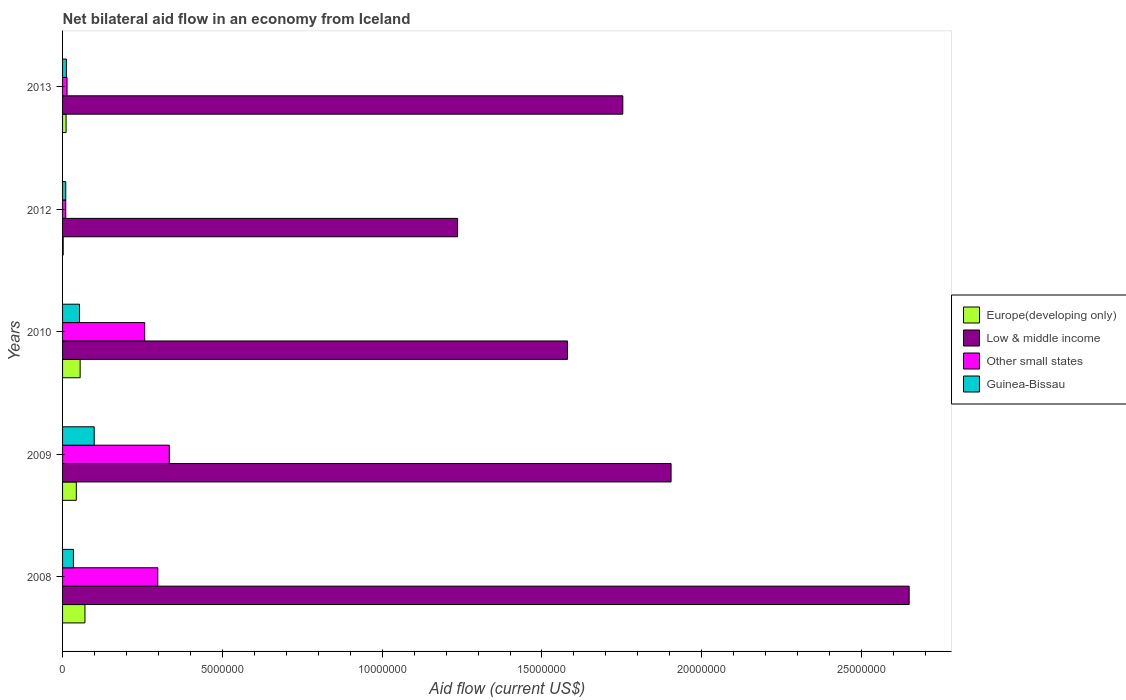Are the number of bars per tick equal to the number of legend labels?
Your answer should be very brief. Yes. How many bars are there on the 5th tick from the bottom?
Ensure brevity in your answer.  4. In how many cases, is the number of bars for a given year not equal to the number of legend labels?
Your response must be concise. 0. What is the net bilateral aid flow in Europe(developing only) in 2013?
Your response must be concise. 1.10e+05. Across all years, what is the maximum net bilateral aid flow in Guinea-Bissau?
Make the answer very short. 9.90e+05. Across all years, what is the minimum net bilateral aid flow in Low & middle income?
Provide a succinct answer. 1.24e+07. What is the total net bilateral aid flow in Guinea-Bissau in the graph?
Your answer should be very brief. 2.08e+06. What is the difference between the net bilateral aid flow in Guinea-Bissau in 2008 and that in 2012?
Ensure brevity in your answer.  2.40e+05. What is the difference between the net bilateral aid flow in Other small states in 2008 and the net bilateral aid flow in Low & middle income in 2012?
Provide a short and direct response. -9.38e+06. What is the average net bilateral aid flow in Europe(developing only) per year?
Ensure brevity in your answer.  3.62e+05. In the year 2008, what is the difference between the net bilateral aid flow in Other small states and net bilateral aid flow in Guinea-Bissau?
Your response must be concise. 2.64e+06. In how many years, is the net bilateral aid flow in Low & middle income greater than 15000000 US$?
Provide a short and direct response. 4. What is the ratio of the net bilateral aid flow in Europe(developing only) in 2009 to that in 2012?
Your response must be concise. 21.5. Is the net bilateral aid flow in Europe(developing only) in 2010 less than that in 2012?
Your response must be concise. No. What is the difference between the highest and the lowest net bilateral aid flow in Europe(developing only)?
Offer a terse response. 6.80e+05. In how many years, is the net bilateral aid flow in Other small states greater than the average net bilateral aid flow in Other small states taken over all years?
Keep it short and to the point. 3. Is the sum of the net bilateral aid flow in Other small states in 2012 and 2013 greater than the maximum net bilateral aid flow in Europe(developing only) across all years?
Keep it short and to the point. No. What does the 2nd bar from the top in 2009 represents?
Offer a terse response. Other small states. What does the 2nd bar from the bottom in 2013 represents?
Give a very brief answer. Low & middle income. Is it the case that in every year, the sum of the net bilateral aid flow in Other small states and net bilateral aid flow in Guinea-Bissau is greater than the net bilateral aid flow in Low & middle income?
Your response must be concise. No. Are all the bars in the graph horizontal?
Make the answer very short. Yes. How many legend labels are there?
Offer a very short reply. 4. What is the title of the graph?
Offer a terse response. Net bilateral aid flow in an economy from Iceland. What is the Aid flow (current US$) of Europe(developing only) in 2008?
Your answer should be very brief. 7.00e+05. What is the Aid flow (current US$) in Low & middle income in 2008?
Your response must be concise. 2.65e+07. What is the Aid flow (current US$) in Other small states in 2008?
Ensure brevity in your answer.  2.98e+06. What is the Aid flow (current US$) of Guinea-Bissau in 2008?
Ensure brevity in your answer.  3.40e+05. What is the Aid flow (current US$) in Europe(developing only) in 2009?
Your answer should be compact. 4.30e+05. What is the Aid flow (current US$) in Low & middle income in 2009?
Provide a short and direct response. 1.90e+07. What is the Aid flow (current US$) of Other small states in 2009?
Keep it short and to the point. 3.34e+06. What is the Aid flow (current US$) in Guinea-Bissau in 2009?
Ensure brevity in your answer.  9.90e+05. What is the Aid flow (current US$) in Low & middle income in 2010?
Give a very brief answer. 1.58e+07. What is the Aid flow (current US$) of Other small states in 2010?
Offer a very short reply. 2.57e+06. What is the Aid flow (current US$) in Guinea-Bissau in 2010?
Your answer should be very brief. 5.30e+05. What is the Aid flow (current US$) in Low & middle income in 2012?
Offer a very short reply. 1.24e+07. What is the Aid flow (current US$) in Other small states in 2012?
Ensure brevity in your answer.  1.00e+05. What is the Aid flow (current US$) of Guinea-Bissau in 2012?
Provide a succinct answer. 1.00e+05. What is the Aid flow (current US$) of Low & middle income in 2013?
Provide a succinct answer. 1.75e+07. Across all years, what is the maximum Aid flow (current US$) in Low & middle income?
Give a very brief answer. 2.65e+07. Across all years, what is the maximum Aid flow (current US$) in Other small states?
Offer a very short reply. 3.34e+06. Across all years, what is the maximum Aid flow (current US$) in Guinea-Bissau?
Your answer should be compact. 9.90e+05. Across all years, what is the minimum Aid flow (current US$) in Low & middle income?
Your answer should be very brief. 1.24e+07. What is the total Aid flow (current US$) of Europe(developing only) in the graph?
Provide a short and direct response. 1.81e+06. What is the total Aid flow (current US$) of Low & middle income in the graph?
Make the answer very short. 9.12e+07. What is the total Aid flow (current US$) of Other small states in the graph?
Offer a terse response. 9.13e+06. What is the total Aid flow (current US$) in Guinea-Bissau in the graph?
Your answer should be compact. 2.08e+06. What is the difference between the Aid flow (current US$) of Low & middle income in 2008 and that in 2009?
Offer a very short reply. 7.45e+06. What is the difference between the Aid flow (current US$) in Other small states in 2008 and that in 2009?
Provide a succinct answer. -3.60e+05. What is the difference between the Aid flow (current US$) in Guinea-Bissau in 2008 and that in 2009?
Ensure brevity in your answer.  -6.50e+05. What is the difference between the Aid flow (current US$) of Europe(developing only) in 2008 and that in 2010?
Make the answer very short. 1.50e+05. What is the difference between the Aid flow (current US$) of Low & middle income in 2008 and that in 2010?
Keep it short and to the point. 1.07e+07. What is the difference between the Aid flow (current US$) of Europe(developing only) in 2008 and that in 2012?
Your answer should be compact. 6.80e+05. What is the difference between the Aid flow (current US$) of Low & middle income in 2008 and that in 2012?
Make the answer very short. 1.41e+07. What is the difference between the Aid flow (current US$) in Other small states in 2008 and that in 2012?
Your answer should be very brief. 2.88e+06. What is the difference between the Aid flow (current US$) of Guinea-Bissau in 2008 and that in 2012?
Your answer should be very brief. 2.40e+05. What is the difference between the Aid flow (current US$) of Europe(developing only) in 2008 and that in 2013?
Your answer should be very brief. 5.90e+05. What is the difference between the Aid flow (current US$) of Low & middle income in 2008 and that in 2013?
Provide a succinct answer. 8.96e+06. What is the difference between the Aid flow (current US$) in Other small states in 2008 and that in 2013?
Keep it short and to the point. 2.84e+06. What is the difference between the Aid flow (current US$) of Europe(developing only) in 2009 and that in 2010?
Ensure brevity in your answer.  -1.20e+05. What is the difference between the Aid flow (current US$) of Low & middle income in 2009 and that in 2010?
Offer a very short reply. 3.24e+06. What is the difference between the Aid flow (current US$) in Other small states in 2009 and that in 2010?
Ensure brevity in your answer.  7.70e+05. What is the difference between the Aid flow (current US$) of Europe(developing only) in 2009 and that in 2012?
Provide a succinct answer. 4.10e+05. What is the difference between the Aid flow (current US$) of Low & middle income in 2009 and that in 2012?
Offer a terse response. 6.68e+06. What is the difference between the Aid flow (current US$) of Other small states in 2009 and that in 2012?
Your response must be concise. 3.24e+06. What is the difference between the Aid flow (current US$) of Guinea-Bissau in 2009 and that in 2012?
Give a very brief answer. 8.90e+05. What is the difference between the Aid flow (current US$) of Low & middle income in 2009 and that in 2013?
Your answer should be compact. 1.51e+06. What is the difference between the Aid flow (current US$) in Other small states in 2009 and that in 2013?
Keep it short and to the point. 3.20e+06. What is the difference between the Aid flow (current US$) in Guinea-Bissau in 2009 and that in 2013?
Give a very brief answer. 8.70e+05. What is the difference between the Aid flow (current US$) in Europe(developing only) in 2010 and that in 2012?
Your answer should be compact. 5.30e+05. What is the difference between the Aid flow (current US$) in Low & middle income in 2010 and that in 2012?
Offer a very short reply. 3.44e+06. What is the difference between the Aid flow (current US$) in Other small states in 2010 and that in 2012?
Give a very brief answer. 2.47e+06. What is the difference between the Aid flow (current US$) in Guinea-Bissau in 2010 and that in 2012?
Your answer should be very brief. 4.30e+05. What is the difference between the Aid flow (current US$) in Europe(developing only) in 2010 and that in 2013?
Your answer should be compact. 4.40e+05. What is the difference between the Aid flow (current US$) in Low & middle income in 2010 and that in 2013?
Offer a terse response. -1.73e+06. What is the difference between the Aid flow (current US$) in Other small states in 2010 and that in 2013?
Give a very brief answer. 2.43e+06. What is the difference between the Aid flow (current US$) in Guinea-Bissau in 2010 and that in 2013?
Offer a terse response. 4.10e+05. What is the difference between the Aid flow (current US$) in Europe(developing only) in 2012 and that in 2013?
Provide a succinct answer. -9.00e+04. What is the difference between the Aid flow (current US$) in Low & middle income in 2012 and that in 2013?
Keep it short and to the point. -5.17e+06. What is the difference between the Aid flow (current US$) of Guinea-Bissau in 2012 and that in 2013?
Your response must be concise. -2.00e+04. What is the difference between the Aid flow (current US$) of Europe(developing only) in 2008 and the Aid flow (current US$) of Low & middle income in 2009?
Offer a very short reply. -1.83e+07. What is the difference between the Aid flow (current US$) in Europe(developing only) in 2008 and the Aid flow (current US$) in Other small states in 2009?
Provide a succinct answer. -2.64e+06. What is the difference between the Aid flow (current US$) of Low & middle income in 2008 and the Aid flow (current US$) of Other small states in 2009?
Ensure brevity in your answer.  2.32e+07. What is the difference between the Aid flow (current US$) in Low & middle income in 2008 and the Aid flow (current US$) in Guinea-Bissau in 2009?
Offer a terse response. 2.55e+07. What is the difference between the Aid flow (current US$) of Other small states in 2008 and the Aid flow (current US$) of Guinea-Bissau in 2009?
Your answer should be compact. 1.99e+06. What is the difference between the Aid flow (current US$) of Europe(developing only) in 2008 and the Aid flow (current US$) of Low & middle income in 2010?
Your answer should be compact. -1.51e+07. What is the difference between the Aid flow (current US$) in Europe(developing only) in 2008 and the Aid flow (current US$) in Other small states in 2010?
Keep it short and to the point. -1.87e+06. What is the difference between the Aid flow (current US$) of Low & middle income in 2008 and the Aid flow (current US$) of Other small states in 2010?
Your answer should be compact. 2.39e+07. What is the difference between the Aid flow (current US$) in Low & middle income in 2008 and the Aid flow (current US$) in Guinea-Bissau in 2010?
Provide a succinct answer. 2.60e+07. What is the difference between the Aid flow (current US$) of Other small states in 2008 and the Aid flow (current US$) of Guinea-Bissau in 2010?
Your answer should be compact. 2.45e+06. What is the difference between the Aid flow (current US$) in Europe(developing only) in 2008 and the Aid flow (current US$) in Low & middle income in 2012?
Ensure brevity in your answer.  -1.17e+07. What is the difference between the Aid flow (current US$) of Low & middle income in 2008 and the Aid flow (current US$) of Other small states in 2012?
Offer a terse response. 2.64e+07. What is the difference between the Aid flow (current US$) of Low & middle income in 2008 and the Aid flow (current US$) of Guinea-Bissau in 2012?
Offer a terse response. 2.64e+07. What is the difference between the Aid flow (current US$) of Other small states in 2008 and the Aid flow (current US$) of Guinea-Bissau in 2012?
Offer a very short reply. 2.88e+06. What is the difference between the Aid flow (current US$) of Europe(developing only) in 2008 and the Aid flow (current US$) of Low & middle income in 2013?
Provide a succinct answer. -1.68e+07. What is the difference between the Aid flow (current US$) in Europe(developing only) in 2008 and the Aid flow (current US$) in Other small states in 2013?
Give a very brief answer. 5.60e+05. What is the difference between the Aid flow (current US$) of Europe(developing only) in 2008 and the Aid flow (current US$) of Guinea-Bissau in 2013?
Offer a terse response. 5.80e+05. What is the difference between the Aid flow (current US$) in Low & middle income in 2008 and the Aid flow (current US$) in Other small states in 2013?
Offer a very short reply. 2.64e+07. What is the difference between the Aid flow (current US$) of Low & middle income in 2008 and the Aid flow (current US$) of Guinea-Bissau in 2013?
Make the answer very short. 2.64e+07. What is the difference between the Aid flow (current US$) of Other small states in 2008 and the Aid flow (current US$) of Guinea-Bissau in 2013?
Offer a terse response. 2.86e+06. What is the difference between the Aid flow (current US$) in Europe(developing only) in 2009 and the Aid flow (current US$) in Low & middle income in 2010?
Offer a very short reply. -1.54e+07. What is the difference between the Aid flow (current US$) of Europe(developing only) in 2009 and the Aid flow (current US$) of Other small states in 2010?
Give a very brief answer. -2.14e+06. What is the difference between the Aid flow (current US$) in Low & middle income in 2009 and the Aid flow (current US$) in Other small states in 2010?
Provide a short and direct response. 1.65e+07. What is the difference between the Aid flow (current US$) in Low & middle income in 2009 and the Aid flow (current US$) in Guinea-Bissau in 2010?
Ensure brevity in your answer.  1.85e+07. What is the difference between the Aid flow (current US$) of Other small states in 2009 and the Aid flow (current US$) of Guinea-Bissau in 2010?
Offer a terse response. 2.81e+06. What is the difference between the Aid flow (current US$) in Europe(developing only) in 2009 and the Aid flow (current US$) in Low & middle income in 2012?
Offer a very short reply. -1.19e+07. What is the difference between the Aid flow (current US$) in Europe(developing only) in 2009 and the Aid flow (current US$) in Guinea-Bissau in 2012?
Your answer should be very brief. 3.30e+05. What is the difference between the Aid flow (current US$) of Low & middle income in 2009 and the Aid flow (current US$) of Other small states in 2012?
Offer a very short reply. 1.89e+07. What is the difference between the Aid flow (current US$) of Low & middle income in 2009 and the Aid flow (current US$) of Guinea-Bissau in 2012?
Your answer should be compact. 1.89e+07. What is the difference between the Aid flow (current US$) of Other small states in 2009 and the Aid flow (current US$) of Guinea-Bissau in 2012?
Your answer should be compact. 3.24e+06. What is the difference between the Aid flow (current US$) in Europe(developing only) in 2009 and the Aid flow (current US$) in Low & middle income in 2013?
Provide a short and direct response. -1.71e+07. What is the difference between the Aid flow (current US$) in Low & middle income in 2009 and the Aid flow (current US$) in Other small states in 2013?
Give a very brief answer. 1.89e+07. What is the difference between the Aid flow (current US$) of Low & middle income in 2009 and the Aid flow (current US$) of Guinea-Bissau in 2013?
Your response must be concise. 1.89e+07. What is the difference between the Aid flow (current US$) of Other small states in 2009 and the Aid flow (current US$) of Guinea-Bissau in 2013?
Your answer should be compact. 3.22e+06. What is the difference between the Aid flow (current US$) of Europe(developing only) in 2010 and the Aid flow (current US$) of Low & middle income in 2012?
Provide a short and direct response. -1.18e+07. What is the difference between the Aid flow (current US$) of Europe(developing only) in 2010 and the Aid flow (current US$) of Other small states in 2012?
Your answer should be very brief. 4.50e+05. What is the difference between the Aid flow (current US$) in Low & middle income in 2010 and the Aid flow (current US$) in Other small states in 2012?
Make the answer very short. 1.57e+07. What is the difference between the Aid flow (current US$) in Low & middle income in 2010 and the Aid flow (current US$) in Guinea-Bissau in 2012?
Offer a terse response. 1.57e+07. What is the difference between the Aid flow (current US$) in Other small states in 2010 and the Aid flow (current US$) in Guinea-Bissau in 2012?
Provide a short and direct response. 2.47e+06. What is the difference between the Aid flow (current US$) in Europe(developing only) in 2010 and the Aid flow (current US$) in Low & middle income in 2013?
Provide a succinct answer. -1.70e+07. What is the difference between the Aid flow (current US$) in Europe(developing only) in 2010 and the Aid flow (current US$) in Other small states in 2013?
Give a very brief answer. 4.10e+05. What is the difference between the Aid flow (current US$) in Low & middle income in 2010 and the Aid flow (current US$) in Other small states in 2013?
Your answer should be compact. 1.57e+07. What is the difference between the Aid flow (current US$) of Low & middle income in 2010 and the Aid flow (current US$) of Guinea-Bissau in 2013?
Keep it short and to the point. 1.57e+07. What is the difference between the Aid flow (current US$) in Other small states in 2010 and the Aid flow (current US$) in Guinea-Bissau in 2013?
Keep it short and to the point. 2.45e+06. What is the difference between the Aid flow (current US$) of Europe(developing only) in 2012 and the Aid flow (current US$) of Low & middle income in 2013?
Ensure brevity in your answer.  -1.75e+07. What is the difference between the Aid flow (current US$) of Europe(developing only) in 2012 and the Aid flow (current US$) of Guinea-Bissau in 2013?
Give a very brief answer. -1.00e+05. What is the difference between the Aid flow (current US$) of Low & middle income in 2012 and the Aid flow (current US$) of Other small states in 2013?
Provide a short and direct response. 1.22e+07. What is the difference between the Aid flow (current US$) in Low & middle income in 2012 and the Aid flow (current US$) in Guinea-Bissau in 2013?
Make the answer very short. 1.22e+07. What is the difference between the Aid flow (current US$) of Other small states in 2012 and the Aid flow (current US$) of Guinea-Bissau in 2013?
Offer a terse response. -2.00e+04. What is the average Aid flow (current US$) of Europe(developing only) per year?
Make the answer very short. 3.62e+05. What is the average Aid flow (current US$) in Low & middle income per year?
Provide a succinct answer. 1.82e+07. What is the average Aid flow (current US$) of Other small states per year?
Ensure brevity in your answer.  1.83e+06. What is the average Aid flow (current US$) of Guinea-Bissau per year?
Your answer should be very brief. 4.16e+05. In the year 2008, what is the difference between the Aid flow (current US$) in Europe(developing only) and Aid flow (current US$) in Low & middle income?
Offer a terse response. -2.58e+07. In the year 2008, what is the difference between the Aid flow (current US$) of Europe(developing only) and Aid flow (current US$) of Other small states?
Make the answer very short. -2.28e+06. In the year 2008, what is the difference between the Aid flow (current US$) of Europe(developing only) and Aid flow (current US$) of Guinea-Bissau?
Offer a terse response. 3.60e+05. In the year 2008, what is the difference between the Aid flow (current US$) in Low & middle income and Aid flow (current US$) in Other small states?
Your answer should be compact. 2.35e+07. In the year 2008, what is the difference between the Aid flow (current US$) of Low & middle income and Aid flow (current US$) of Guinea-Bissau?
Provide a short and direct response. 2.62e+07. In the year 2008, what is the difference between the Aid flow (current US$) in Other small states and Aid flow (current US$) in Guinea-Bissau?
Offer a very short reply. 2.64e+06. In the year 2009, what is the difference between the Aid flow (current US$) in Europe(developing only) and Aid flow (current US$) in Low & middle income?
Ensure brevity in your answer.  -1.86e+07. In the year 2009, what is the difference between the Aid flow (current US$) in Europe(developing only) and Aid flow (current US$) in Other small states?
Keep it short and to the point. -2.91e+06. In the year 2009, what is the difference between the Aid flow (current US$) of Europe(developing only) and Aid flow (current US$) of Guinea-Bissau?
Your answer should be compact. -5.60e+05. In the year 2009, what is the difference between the Aid flow (current US$) in Low & middle income and Aid flow (current US$) in Other small states?
Ensure brevity in your answer.  1.57e+07. In the year 2009, what is the difference between the Aid flow (current US$) in Low & middle income and Aid flow (current US$) in Guinea-Bissau?
Keep it short and to the point. 1.80e+07. In the year 2009, what is the difference between the Aid flow (current US$) in Other small states and Aid flow (current US$) in Guinea-Bissau?
Your answer should be very brief. 2.35e+06. In the year 2010, what is the difference between the Aid flow (current US$) in Europe(developing only) and Aid flow (current US$) in Low & middle income?
Ensure brevity in your answer.  -1.52e+07. In the year 2010, what is the difference between the Aid flow (current US$) of Europe(developing only) and Aid flow (current US$) of Other small states?
Provide a succinct answer. -2.02e+06. In the year 2010, what is the difference between the Aid flow (current US$) in Low & middle income and Aid flow (current US$) in Other small states?
Offer a very short reply. 1.32e+07. In the year 2010, what is the difference between the Aid flow (current US$) in Low & middle income and Aid flow (current US$) in Guinea-Bissau?
Keep it short and to the point. 1.53e+07. In the year 2010, what is the difference between the Aid flow (current US$) in Other small states and Aid flow (current US$) in Guinea-Bissau?
Ensure brevity in your answer.  2.04e+06. In the year 2012, what is the difference between the Aid flow (current US$) in Europe(developing only) and Aid flow (current US$) in Low & middle income?
Keep it short and to the point. -1.23e+07. In the year 2012, what is the difference between the Aid flow (current US$) of Europe(developing only) and Aid flow (current US$) of Guinea-Bissau?
Provide a succinct answer. -8.00e+04. In the year 2012, what is the difference between the Aid flow (current US$) in Low & middle income and Aid flow (current US$) in Other small states?
Your response must be concise. 1.23e+07. In the year 2012, what is the difference between the Aid flow (current US$) in Low & middle income and Aid flow (current US$) in Guinea-Bissau?
Give a very brief answer. 1.23e+07. In the year 2013, what is the difference between the Aid flow (current US$) of Europe(developing only) and Aid flow (current US$) of Low & middle income?
Ensure brevity in your answer.  -1.74e+07. In the year 2013, what is the difference between the Aid flow (current US$) in Low & middle income and Aid flow (current US$) in Other small states?
Offer a very short reply. 1.74e+07. In the year 2013, what is the difference between the Aid flow (current US$) in Low & middle income and Aid flow (current US$) in Guinea-Bissau?
Give a very brief answer. 1.74e+07. In the year 2013, what is the difference between the Aid flow (current US$) of Other small states and Aid flow (current US$) of Guinea-Bissau?
Ensure brevity in your answer.  2.00e+04. What is the ratio of the Aid flow (current US$) in Europe(developing only) in 2008 to that in 2009?
Ensure brevity in your answer.  1.63. What is the ratio of the Aid flow (current US$) of Low & middle income in 2008 to that in 2009?
Provide a short and direct response. 1.39. What is the ratio of the Aid flow (current US$) in Other small states in 2008 to that in 2009?
Give a very brief answer. 0.89. What is the ratio of the Aid flow (current US$) of Guinea-Bissau in 2008 to that in 2009?
Make the answer very short. 0.34. What is the ratio of the Aid flow (current US$) of Europe(developing only) in 2008 to that in 2010?
Your response must be concise. 1.27. What is the ratio of the Aid flow (current US$) of Low & middle income in 2008 to that in 2010?
Provide a succinct answer. 1.68. What is the ratio of the Aid flow (current US$) in Other small states in 2008 to that in 2010?
Offer a terse response. 1.16. What is the ratio of the Aid flow (current US$) of Guinea-Bissau in 2008 to that in 2010?
Ensure brevity in your answer.  0.64. What is the ratio of the Aid flow (current US$) in Europe(developing only) in 2008 to that in 2012?
Your response must be concise. 35. What is the ratio of the Aid flow (current US$) of Low & middle income in 2008 to that in 2012?
Give a very brief answer. 2.14. What is the ratio of the Aid flow (current US$) in Other small states in 2008 to that in 2012?
Provide a succinct answer. 29.8. What is the ratio of the Aid flow (current US$) of Europe(developing only) in 2008 to that in 2013?
Give a very brief answer. 6.36. What is the ratio of the Aid flow (current US$) of Low & middle income in 2008 to that in 2013?
Offer a very short reply. 1.51. What is the ratio of the Aid flow (current US$) in Other small states in 2008 to that in 2013?
Offer a very short reply. 21.29. What is the ratio of the Aid flow (current US$) in Guinea-Bissau in 2008 to that in 2013?
Your response must be concise. 2.83. What is the ratio of the Aid flow (current US$) of Europe(developing only) in 2009 to that in 2010?
Your answer should be compact. 0.78. What is the ratio of the Aid flow (current US$) of Low & middle income in 2009 to that in 2010?
Ensure brevity in your answer.  1.21. What is the ratio of the Aid flow (current US$) in Other small states in 2009 to that in 2010?
Your answer should be very brief. 1.3. What is the ratio of the Aid flow (current US$) of Guinea-Bissau in 2009 to that in 2010?
Offer a very short reply. 1.87. What is the ratio of the Aid flow (current US$) in Low & middle income in 2009 to that in 2012?
Offer a terse response. 1.54. What is the ratio of the Aid flow (current US$) of Other small states in 2009 to that in 2012?
Give a very brief answer. 33.4. What is the ratio of the Aid flow (current US$) of Europe(developing only) in 2009 to that in 2013?
Offer a very short reply. 3.91. What is the ratio of the Aid flow (current US$) of Low & middle income in 2009 to that in 2013?
Make the answer very short. 1.09. What is the ratio of the Aid flow (current US$) in Other small states in 2009 to that in 2013?
Make the answer very short. 23.86. What is the ratio of the Aid flow (current US$) in Guinea-Bissau in 2009 to that in 2013?
Your answer should be very brief. 8.25. What is the ratio of the Aid flow (current US$) in Low & middle income in 2010 to that in 2012?
Your answer should be compact. 1.28. What is the ratio of the Aid flow (current US$) in Other small states in 2010 to that in 2012?
Your response must be concise. 25.7. What is the ratio of the Aid flow (current US$) in Europe(developing only) in 2010 to that in 2013?
Your response must be concise. 5. What is the ratio of the Aid flow (current US$) of Low & middle income in 2010 to that in 2013?
Give a very brief answer. 0.9. What is the ratio of the Aid flow (current US$) of Other small states in 2010 to that in 2013?
Give a very brief answer. 18.36. What is the ratio of the Aid flow (current US$) in Guinea-Bissau in 2010 to that in 2013?
Offer a terse response. 4.42. What is the ratio of the Aid flow (current US$) of Europe(developing only) in 2012 to that in 2013?
Provide a short and direct response. 0.18. What is the ratio of the Aid flow (current US$) of Low & middle income in 2012 to that in 2013?
Your answer should be very brief. 0.71. What is the difference between the highest and the second highest Aid flow (current US$) of Europe(developing only)?
Your answer should be compact. 1.50e+05. What is the difference between the highest and the second highest Aid flow (current US$) in Low & middle income?
Offer a terse response. 7.45e+06. What is the difference between the highest and the second highest Aid flow (current US$) of Other small states?
Provide a short and direct response. 3.60e+05. What is the difference between the highest and the second highest Aid flow (current US$) of Guinea-Bissau?
Ensure brevity in your answer.  4.60e+05. What is the difference between the highest and the lowest Aid flow (current US$) in Europe(developing only)?
Offer a terse response. 6.80e+05. What is the difference between the highest and the lowest Aid flow (current US$) in Low & middle income?
Provide a short and direct response. 1.41e+07. What is the difference between the highest and the lowest Aid flow (current US$) of Other small states?
Provide a succinct answer. 3.24e+06. What is the difference between the highest and the lowest Aid flow (current US$) of Guinea-Bissau?
Keep it short and to the point. 8.90e+05. 